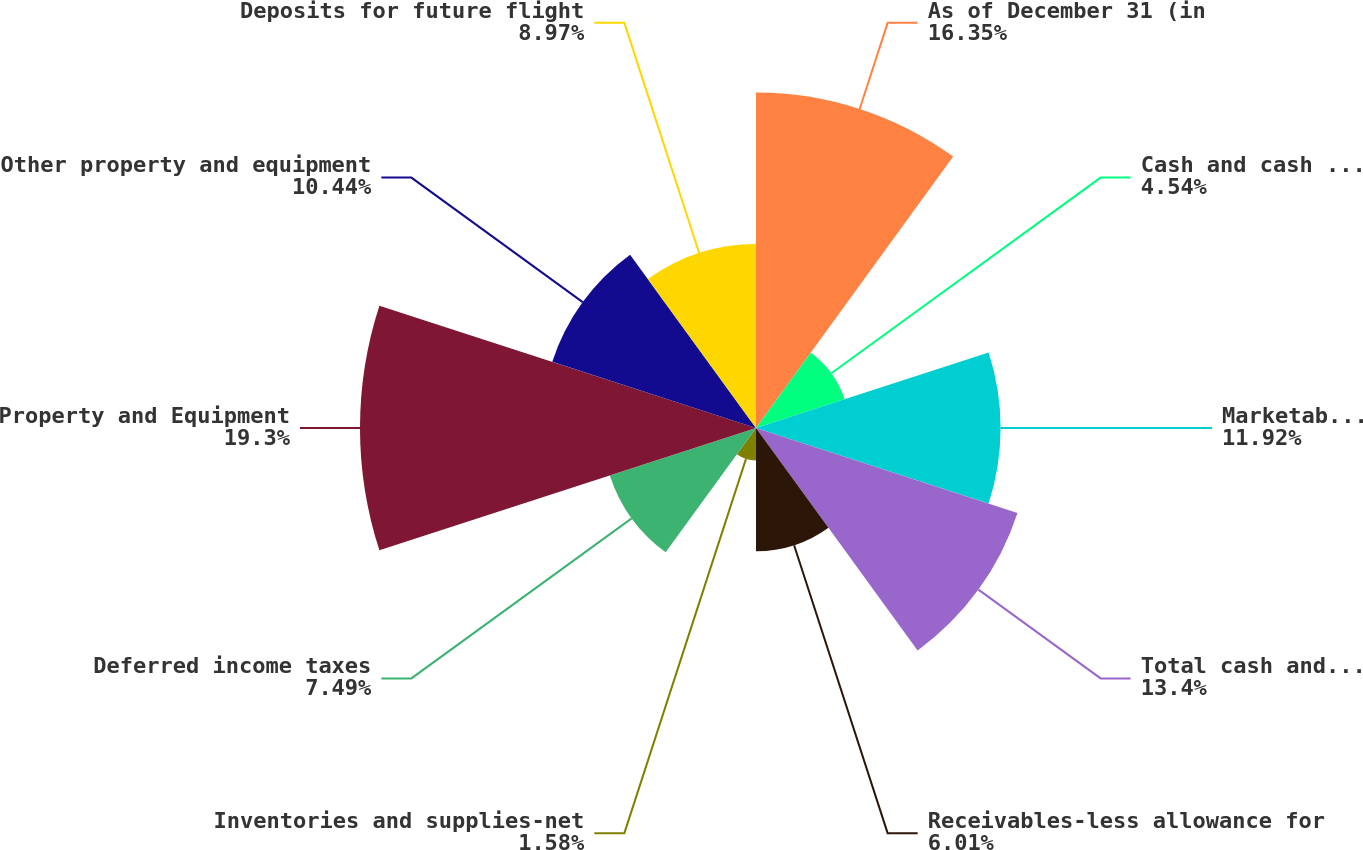Convert chart. <chart><loc_0><loc_0><loc_500><loc_500><pie_chart><fcel>As of December 31 (in<fcel>Cash and cash equivalents<fcel>Marketable securities<fcel>Total cash and marketable<fcel>Receivables-less allowance for<fcel>Inventories and supplies-net<fcel>Deferred income taxes<fcel>Property and Equipment<fcel>Other property and equipment<fcel>Deposits for future flight<nl><fcel>16.35%<fcel>4.54%<fcel>11.92%<fcel>13.4%<fcel>6.01%<fcel>1.58%<fcel>7.49%<fcel>19.3%<fcel>10.44%<fcel>8.97%<nl></chart> 